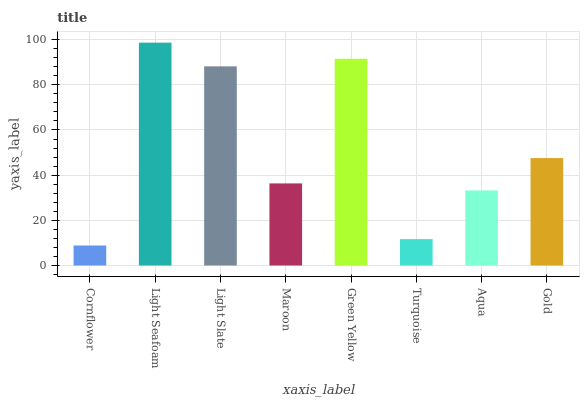Is Cornflower the minimum?
Answer yes or no. Yes. Is Light Seafoam the maximum?
Answer yes or no. Yes. Is Light Slate the minimum?
Answer yes or no. No. Is Light Slate the maximum?
Answer yes or no. No. Is Light Seafoam greater than Light Slate?
Answer yes or no. Yes. Is Light Slate less than Light Seafoam?
Answer yes or no. Yes. Is Light Slate greater than Light Seafoam?
Answer yes or no. No. Is Light Seafoam less than Light Slate?
Answer yes or no. No. Is Gold the high median?
Answer yes or no. Yes. Is Maroon the low median?
Answer yes or no. Yes. Is Light Seafoam the high median?
Answer yes or no. No. Is Cornflower the low median?
Answer yes or no. No. 